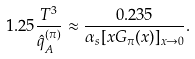<formula> <loc_0><loc_0><loc_500><loc_500>1 . 2 5 \frac { T ^ { 3 } } { \hat { q } _ { A } ^ { ( \pi ) } } \approx \frac { 0 . 2 3 5 } { \alpha _ { s } [ x G _ { \pi } ( x ) ] _ { x \to 0 } } .</formula> 